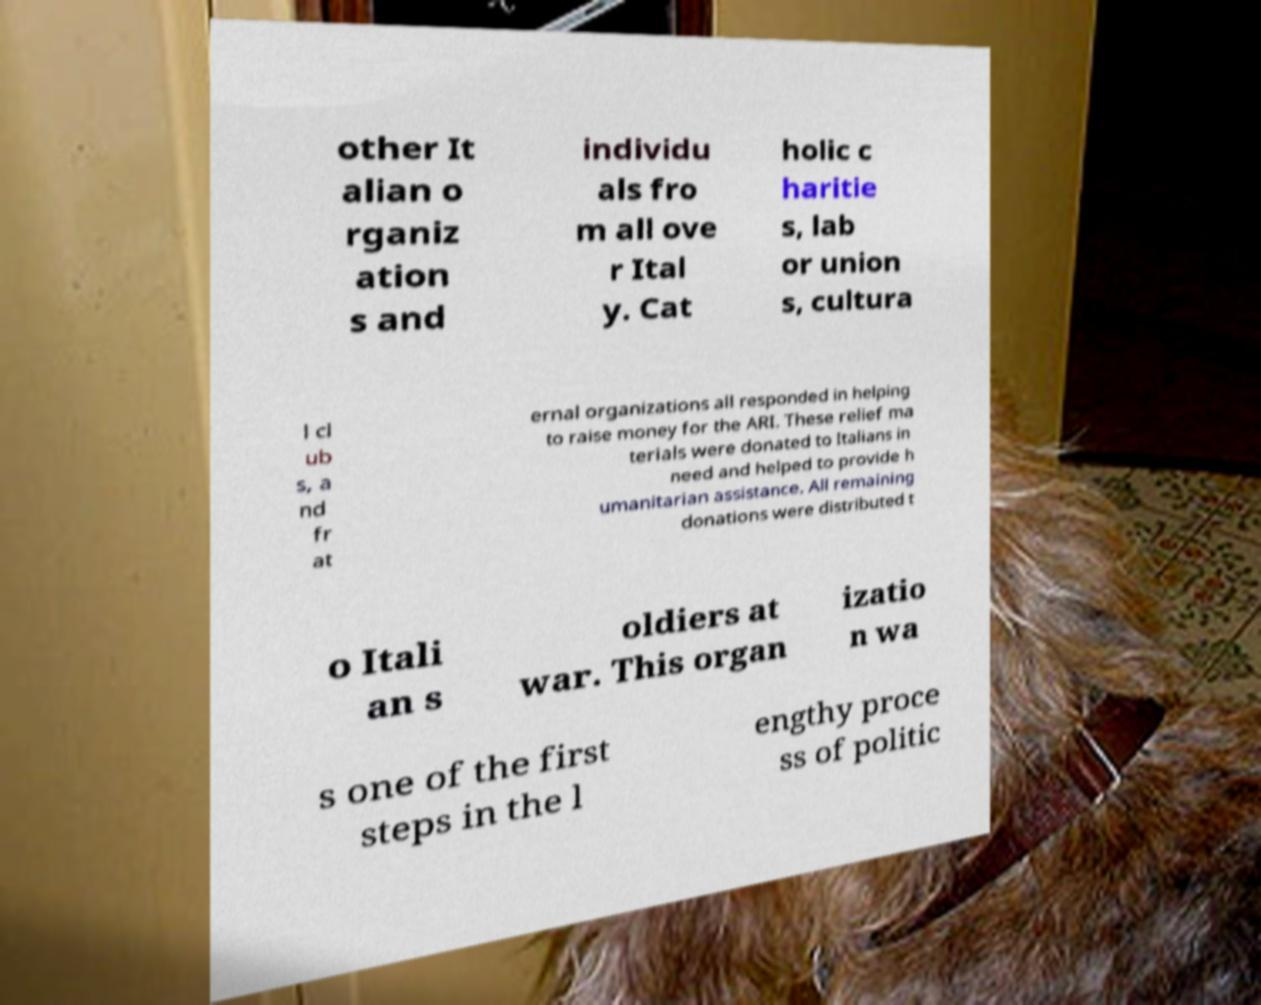Please read and relay the text visible in this image. What does it say? other It alian o rganiz ation s and individu als fro m all ove r Ital y. Cat holic c haritie s, lab or union s, cultura l cl ub s, a nd fr at ernal organizations all responded in helping to raise money for the ARI. These relief ma terials were donated to Italians in need and helped to provide h umanitarian assistance. All remaining donations were distributed t o Itali an s oldiers at war. This organ izatio n wa s one of the first steps in the l engthy proce ss of politic 